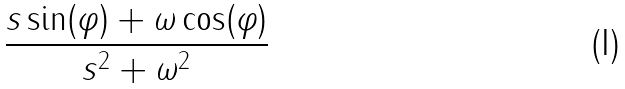<formula> <loc_0><loc_0><loc_500><loc_500>\frac { s \sin ( \varphi ) + \omega \cos ( \varphi ) } { s ^ { 2 } + \omega ^ { 2 } }</formula> 